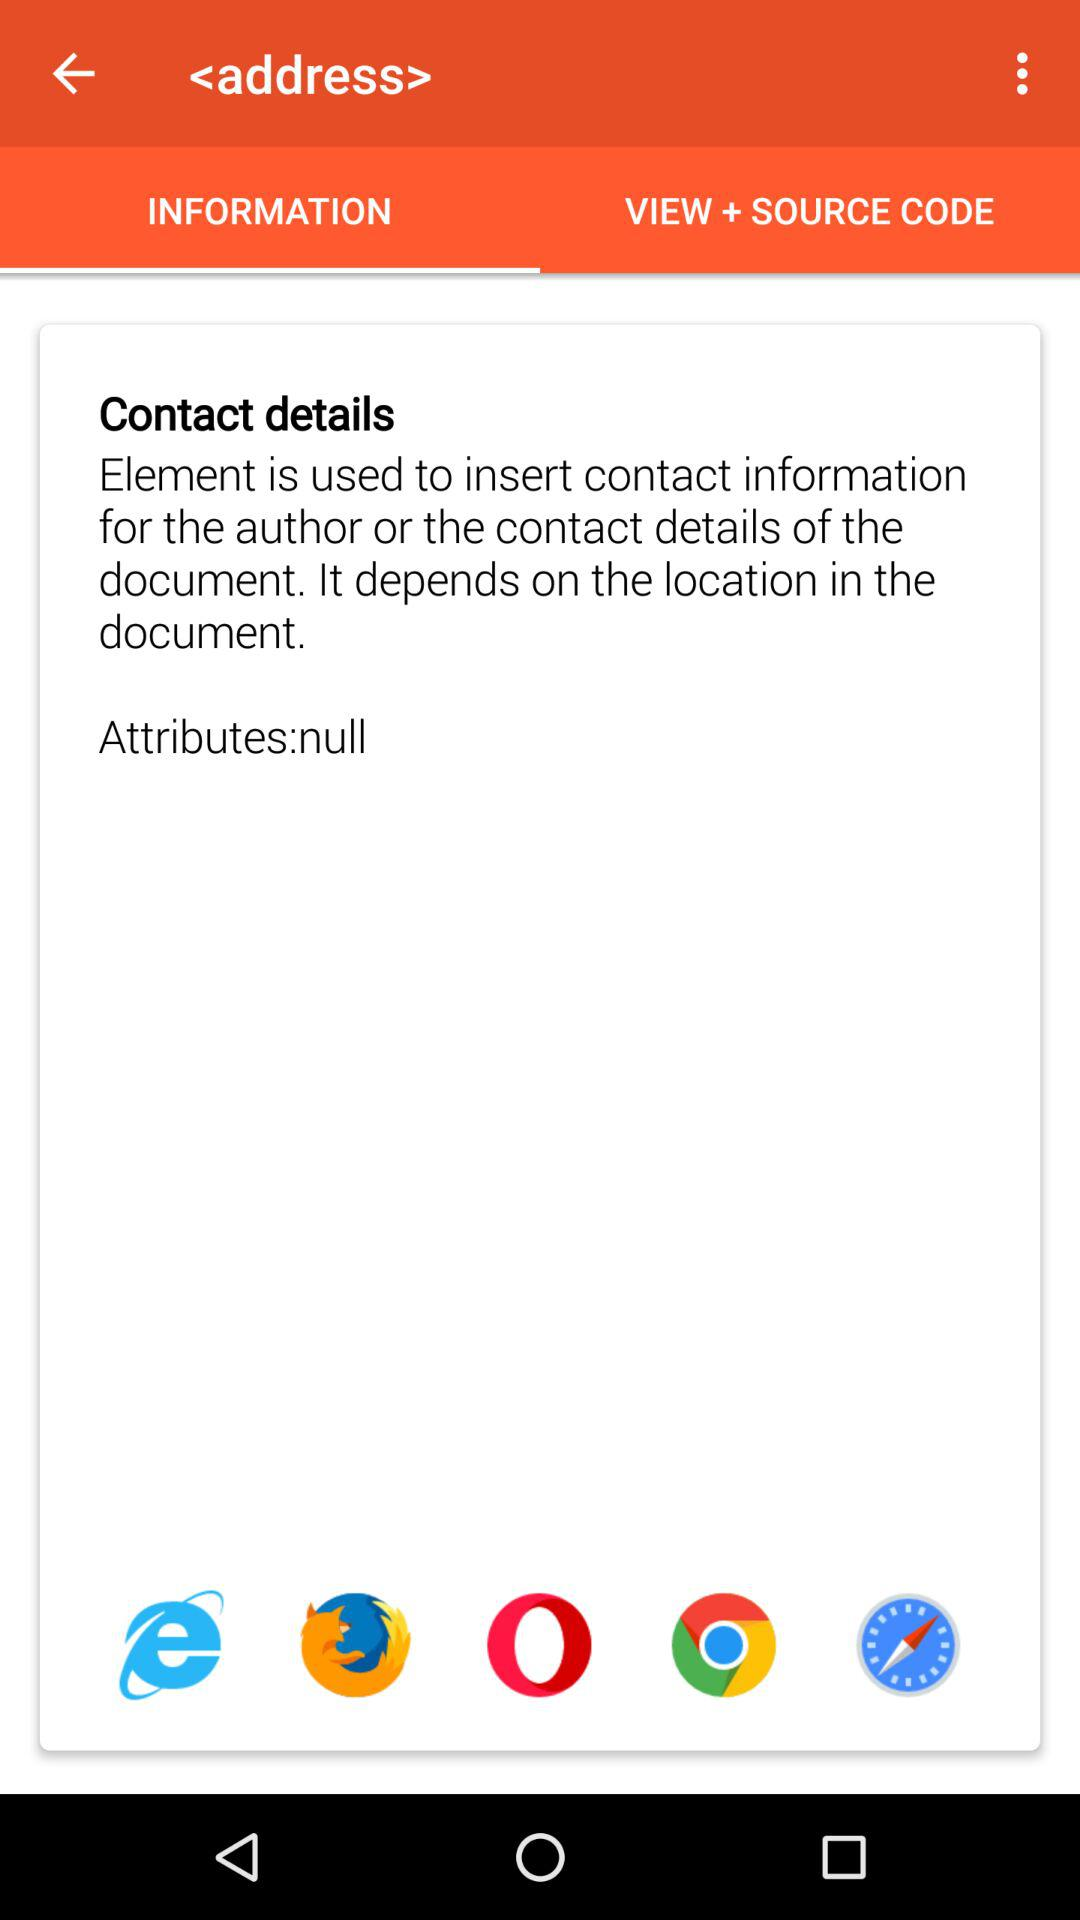Which option is selected? The selected option is "INFORMATION". 